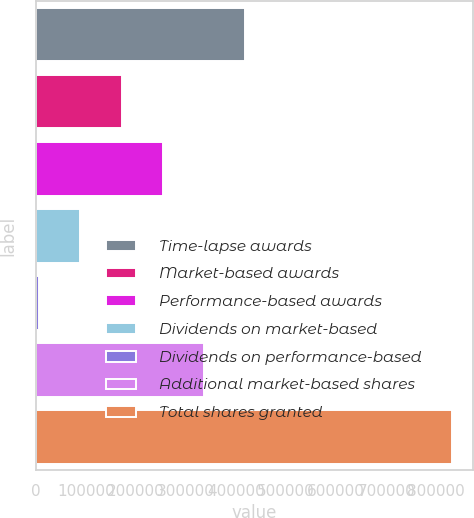Convert chart to OTSL. <chart><loc_0><loc_0><loc_500><loc_500><bar_chart><fcel>Time-lapse awards<fcel>Market-based awards<fcel>Performance-based awards<fcel>Dividends on market-based<fcel>Dividends on performance-based<fcel>Additional market-based shares<fcel>Total shares granted<nl><fcel>418478<fcel>170924<fcel>253442<fcel>88406.1<fcel>5888<fcel>335960<fcel>831069<nl></chart> 